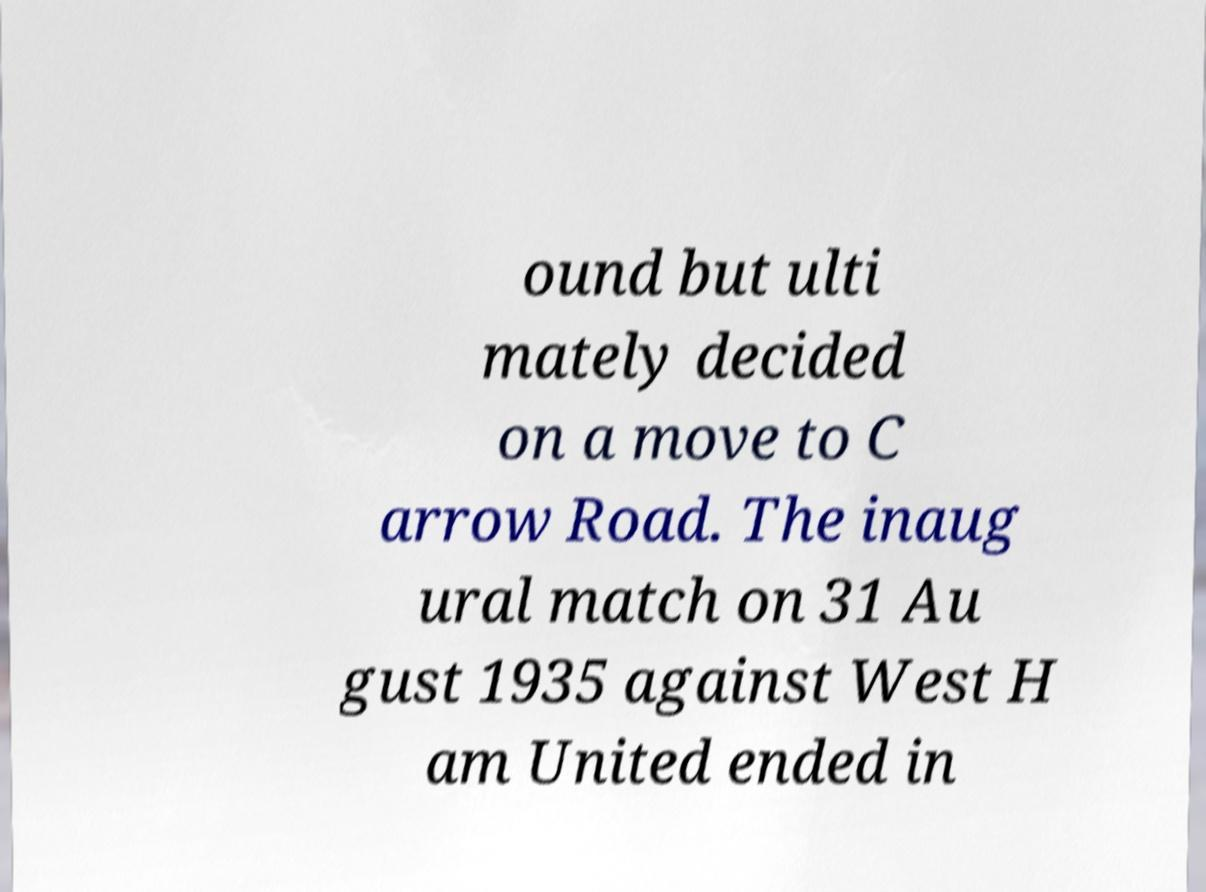Could you extract and type out the text from this image? ound but ulti mately decided on a move to C arrow Road. The inaug ural match on 31 Au gust 1935 against West H am United ended in 